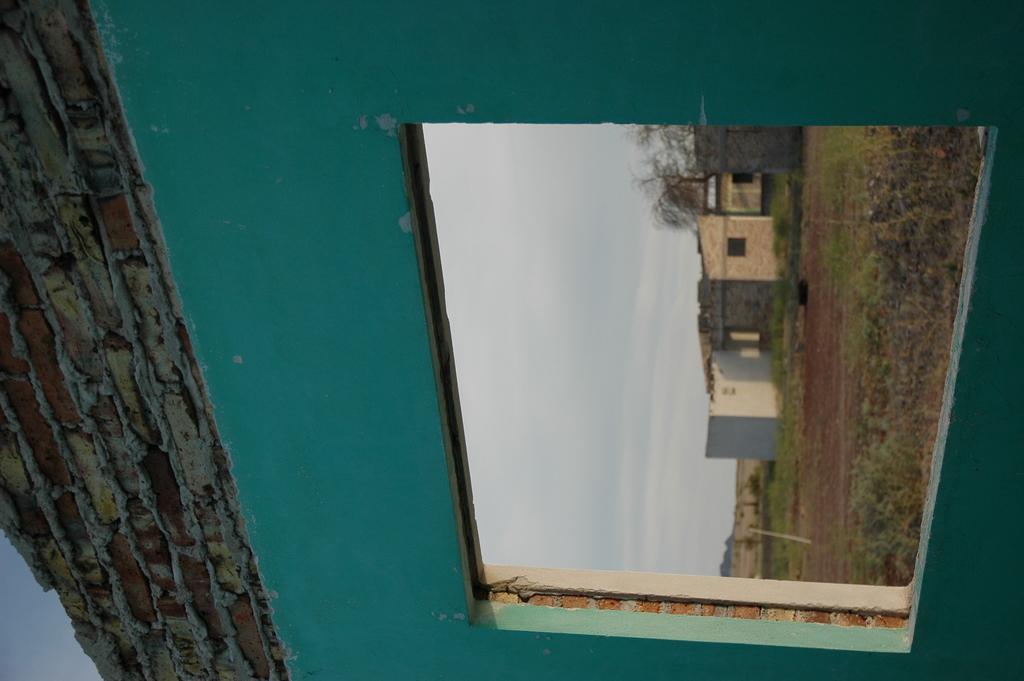Please provide a concise description of this image. In this image, we can see an open window and brick wall. Through the window, we can see the other side view. Here we can see grass, houses, plants, trees and sky. 